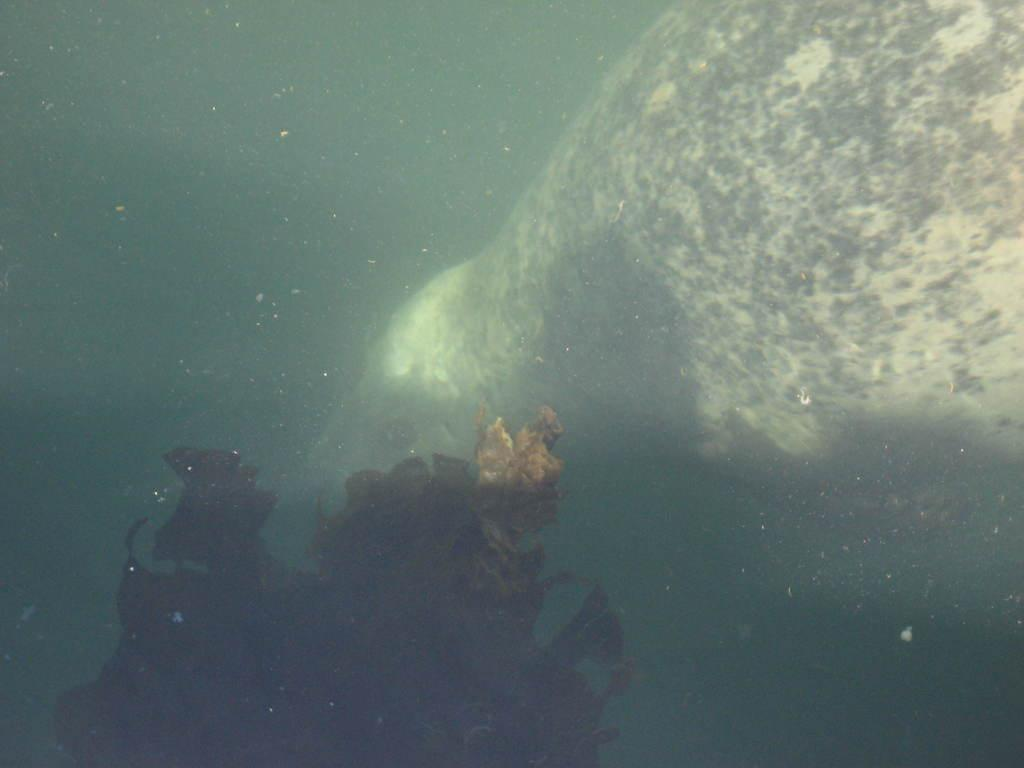What type of plant is in the image? There is a coral plant in the image. Where is the coral plant located? The coral plant is underwater. What other living organisms can be seen in the image? There are fishes visible in the image. What type of cough medicine is visible in the image? There is no cough medicine present in the image; it features a coral plant underwater with fishes. What type of polish is being applied to the coral plant in the image? There is no polish being applied to the coral plant in the image; it is underwater with fishes. 